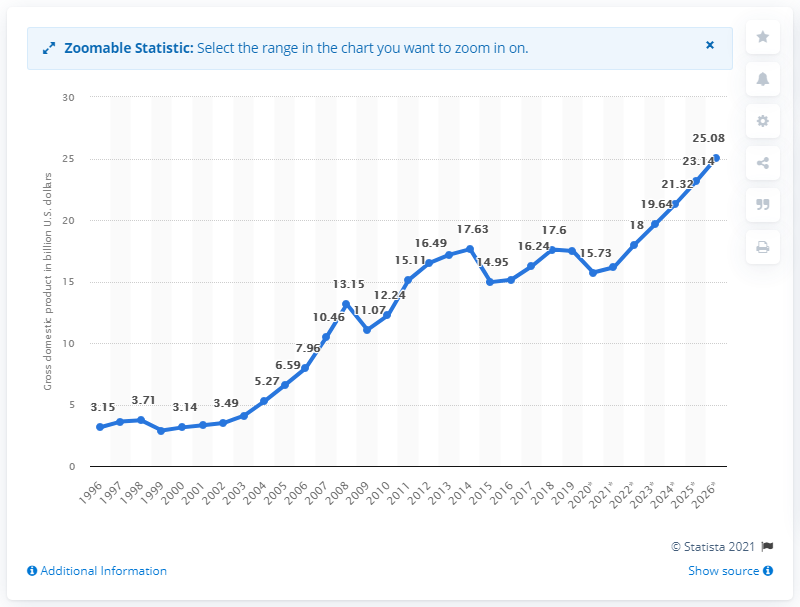Identify some key points in this picture. In 2019, the gross domestic product of Georgia was 17.48. 